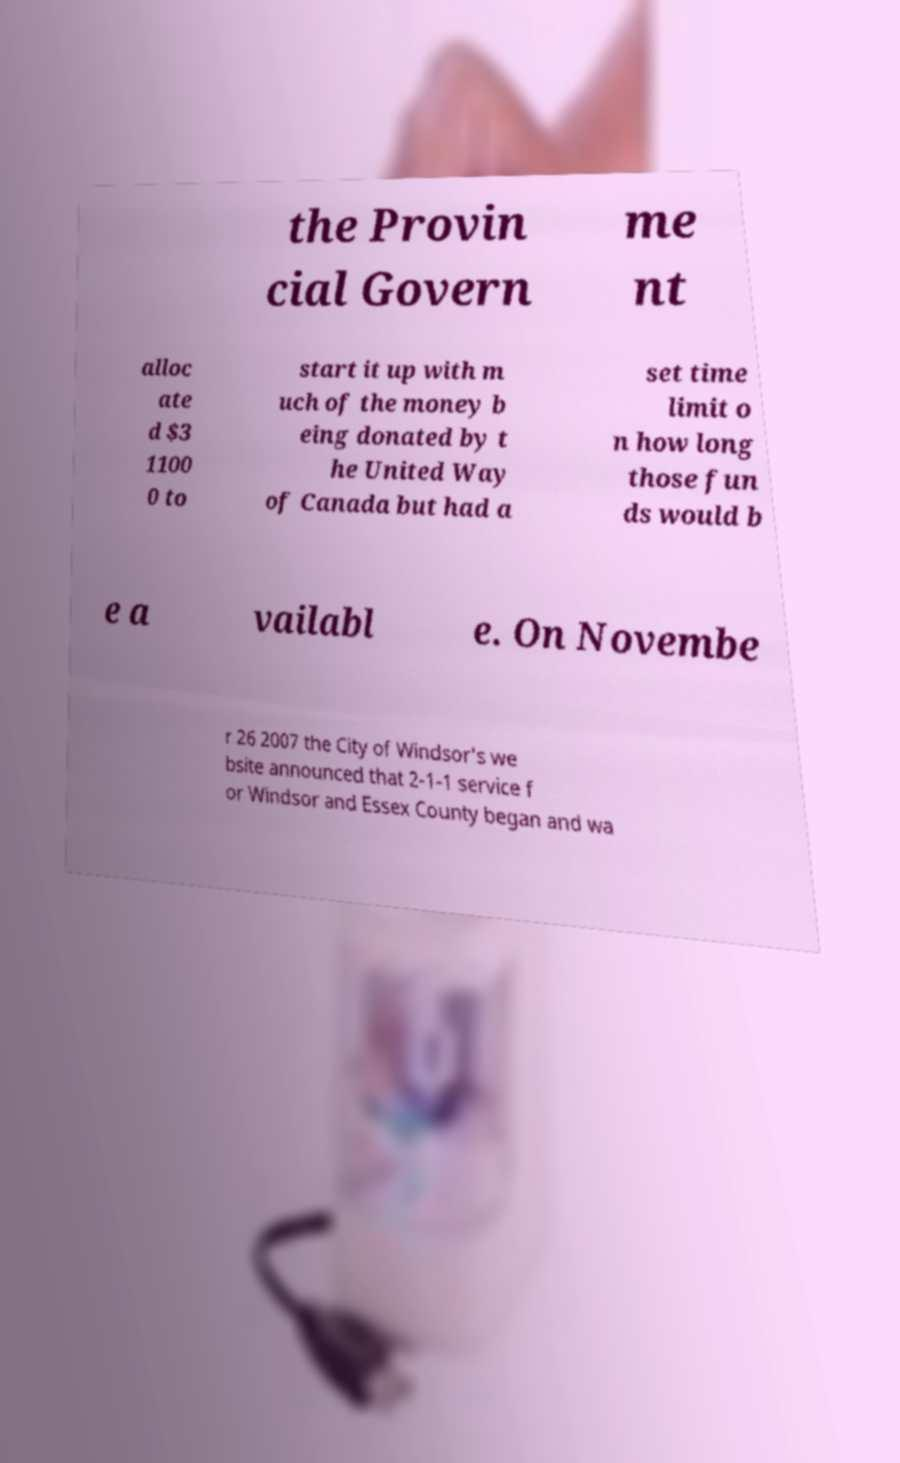There's text embedded in this image that I need extracted. Can you transcribe it verbatim? the Provin cial Govern me nt alloc ate d $3 1100 0 to start it up with m uch of the money b eing donated by t he United Way of Canada but had a set time limit o n how long those fun ds would b e a vailabl e. On Novembe r 26 2007 the City of Windsor's we bsite announced that 2-1-1 service f or Windsor and Essex County began and wa 